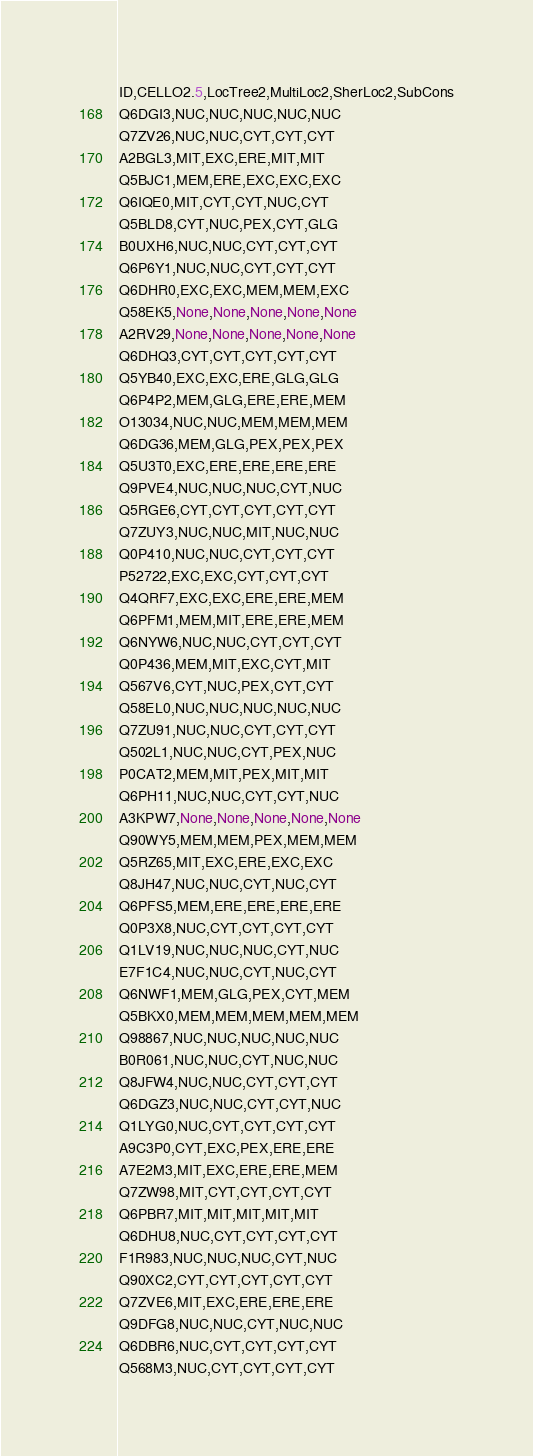<code> <loc_0><loc_0><loc_500><loc_500><_SQL_>ID,CELLO2.5,LocTree2,MultiLoc2,SherLoc2,SubCons
Q6DGI3,NUC,NUC,NUC,NUC,NUC
Q7ZV26,NUC,NUC,CYT,CYT,CYT
A2BGL3,MIT,EXC,ERE,MIT,MIT
Q5BJC1,MEM,ERE,EXC,EXC,EXC
Q6IQE0,MIT,CYT,CYT,NUC,CYT
Q5BLD8,CYT,NUC,PEX,CYT,GLG
B0UXH6,NUC,NUC,CYT,CYT,CYT
Q6P6Y1,NUC,NUC,CYT,CYT,CYT
Q6DHR0,EXC,EXC,MEM,MEM,EXC
Q58EK5,None,None,None,None,None
A2RV29,None,None,None,None,None
Q6DHQ3,CYT,CYT,CYT,CYT,CYT
Q5YB40,EXC,EXC,ERE,GLG,GLG
Q6P4P2,MEM,GLG,ERE,ERE,MEM
O13034,NUC,NUC,MEM,MEM,MEM
Q6DG36,MEM,GLG,PEX,PEX,PEX
Q5U3T0,EXC,ERE,ERE,ERE,ERE
Q9PVE4,NUC,NUC,NUC,CYT,NUC
Q5RGE6,CYT,CYT,CYT,CYT,CYT
Q7ZUY3,NUC,NUC,MIT,NUC,NUC
Q0P410,NUC,NUC,CYT,CYT,CYT
P52722,EXC,EXC,CYT,CYT,CYT
Q4QRF7,EXC,EXC,ERE,ERE,MEM
Q6PFM1,MEM,MIT,ERE,ERE,MEM
Q6NYW6,NUC,NUC,CYT,CYT,CYT
Q0P436,MEM,MIT,EXC,CYT,MIT
Q567V6,CYT,NUC,PEX,CYT,CYT
Q58EL0,NUC,NUC,NUC,NUC,NUC
Q7ZU91,NUC,NUC,CYT,CYT,CYT
Q502L1,NUC,NUC,CYT,PEX,NUC
P0CAT2,MEM,MIT,PEX,MIT,MIT
Q6PH11,NUC,NUC,CYT,CYT,NUC
A3KPW7,None,None,None,None,None
Q90WY5,MEM,MEM,PEX,MEM,MEM
Q5RZ65,MIT,EXC,ERE,EXC,EXC
Q8JH47,NUC,NUC,CYT,NUC,CYT
Q6PFS5,MEM,ERE,ERE,ERE,ERE
Q0P3X8,NUC,CYT,CYT,CYT,CYT
Q1LV19,NUC,NUC,NUC,CYT,NUC
E7F1C4,NUC,NUC,CYT,NUC,CYT
Q6NWF1,MEM,GLG,PEX,CYT,MEM
Q5BKX0,MEM,MEM,MEM,MEM,MEM
Q98867,NUC,NUC,NUC,NUC,NUC
B0R061,NUC,NUC,CYT,NUC,NUC
Q8JFW4,NUC,NUC,CYT,CYT,CYT
Q6DGZ3,NUC,NUC,CYT,CYT,NUC
Q1LYG0,NUC,CYT,CYT,CYT,CYT
A9C3P0,CYT,EXC,PEX,ERE,ERE
A7E2M3,MIT,EXC,ERE,ERE,MEM
Q7ZW98,MIT,CYT,CYT,CYT,CYT
Q6PBR7,MIT,MIT,MIT,MIT,MIT
Q6DHU8,NUC,CYT,CYT,CYT,CYT
F1R983,NUC,NUC,NUC,CYT,NUC
Q90XC2,CYT,CYT,CYT,CYT,CYT
Q7ZVE6,MIT,EXC,ERE,ERE,ERE
Q9DFG8,NUC,NUC,CYT,NUC,NUC
Q6DBR6,NUC,CYT,CYT,CYT,CYT
Q568M3,NUC,CYT,CYT,CYT,CYT</code> 